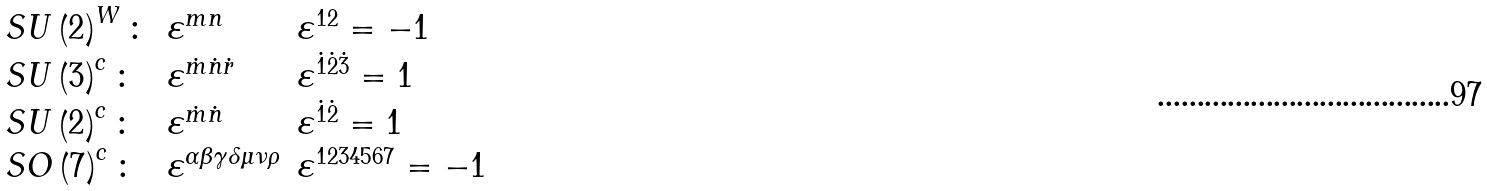<formula> <loc_0><loc_0><loc_500><loc_500>\begin{array} { l l l } S U \left ( 2 \right ) ^ { W } \colon & \varepsilon ^ { m n } & \varepsilon ^ { 1 2 } = - 1 \\ S U \left ( 3 \right ) ^ { c } \colon & \varepsilon ^ { \dot { m } \dot { n } \dot { r } } & \varepsilon ^ { \dot { 1 } \dot { 2 } \dot { 3 } } = 1 \\ S U \left ( 2 \right ) ^ { c } \colon & \varepsilon ^ { \dot { m } \dot { n } } & \varepsilon ^ { \dot { 1 } \dot { 2 } } = 1 \\ S O \left ( 7 \right ) ^ { c } \colon & \varepsilon ^ { \alpha \beta \gamma \delta \mu \nu \rho } & \varepsilon ^ { 1 2 3 4 5 6 7 } = - 1 \end{array}</formula> 